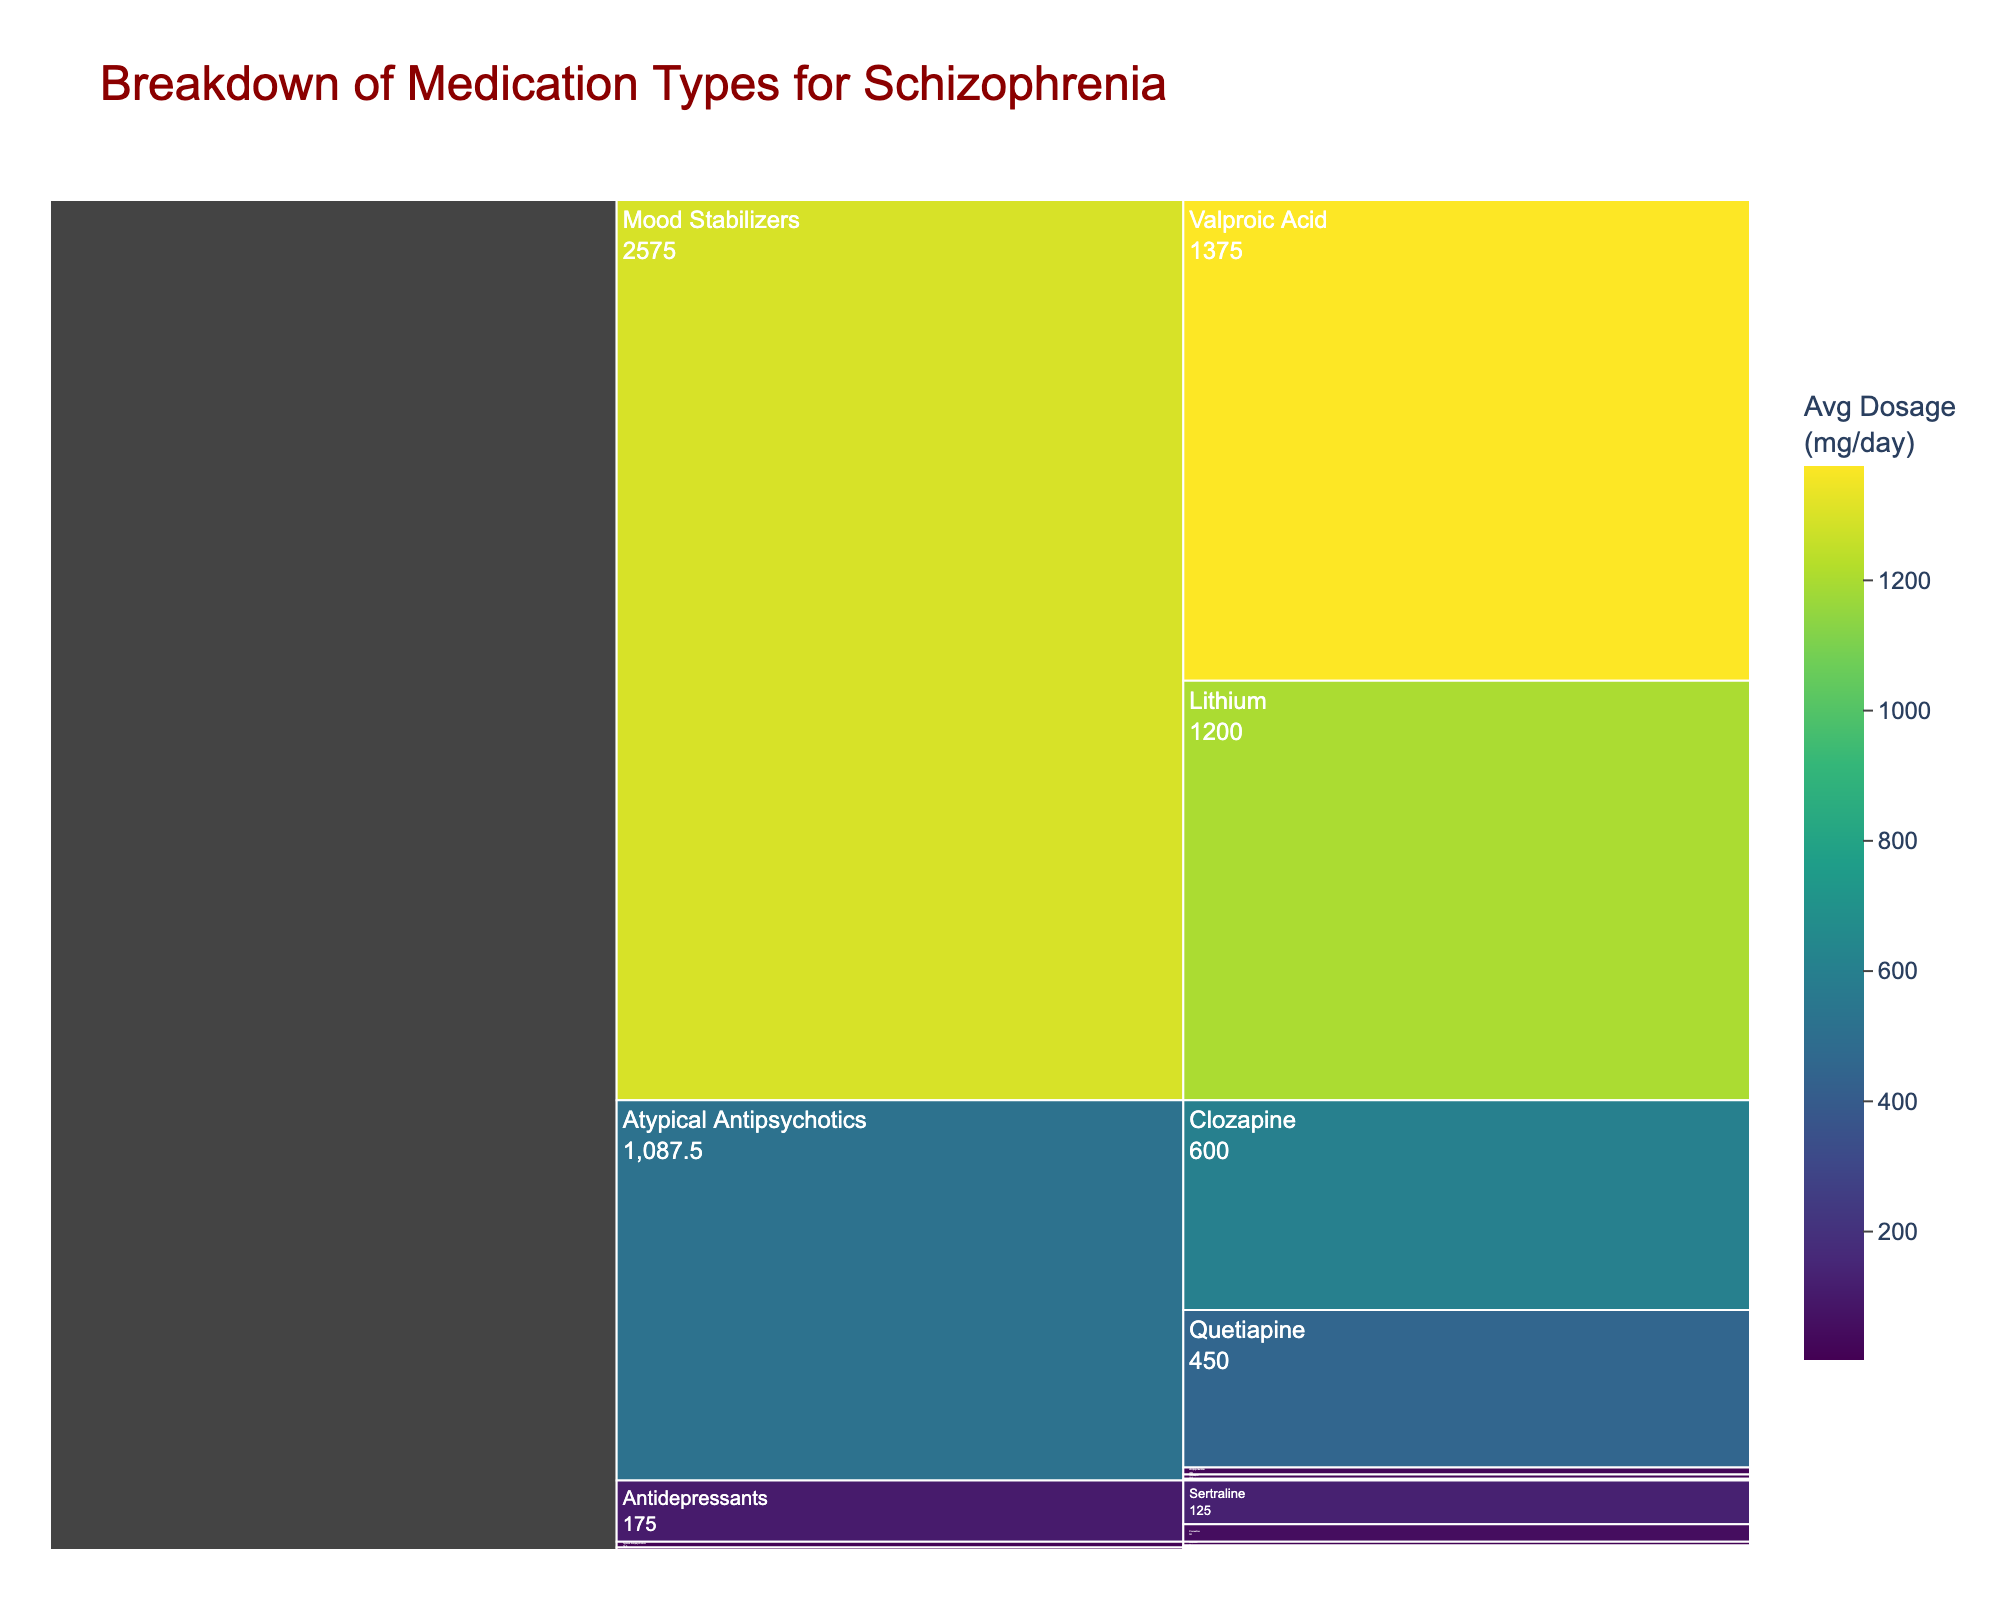How many chemical classes of medications are displayed in the chart? The chart shows different chemical classes under which medications are grouped. By counting the distinct categories on the top level of the icicle chart, we find the number of classes.
Answer: 4 Which medication has the highest average dosage in the chart? To find the medication with the highest average dosage, look for the segment with the highest numeric value in mg/day. Clozapine at 600 mg/day is highest.
Answer: Clozapine What is the total average dosage for all Typical Antipsychotics? Locate all Typical Antipsychotics (Haloperidol and Fluphenazine), then sum up their average dosages: (11 + 5.5) = 16.5 mg/day.
Answer: 16.5 mg/day Which chemical class has the most medications listed? Count the number of medications under each chemical class. Atypical Antipsychotics have the most medications listed.
Answer: Atypical Antipsychotics If you were to categorize the medications with an average dosage of over 500 mg/day, which ones would qualify? Identify the segments with dosages over 500 mg/day by their values in the visual. Both Quetiapine and Clozapine have average dosages over 500 mg/day.
Answer: Quetiapine, Clozapine Which Atypical Antipsychotic has the lowest average dosage? Among the Atypical Antipsychotics (Risperidone, Olanzapine, Quetiapine, Aripiprazole, Clozapine), find the one with the lowest average dosage value. Risperidone has the lowest at 5 mg/day.
Answer: Risperidone How are the colors related to the average dosage in the chart? The chart uses a continuous color scale (Viridis) to represent average dosages. Darker colors typically represent lower dosages, and brighter colors represent higher dosages.
Answer: Dark to bright Do Mood Stabilizers or Antidepressants have higher average dosages, overall? Calculate the average dosage for each category. Mood Stabilizers: (1200 + 1375)/2 = 1287.5 mg/day, Antidepressants: (125 + 50)/2 = 87.5 mg/day. Compare the sums, Mood Stabilizers are higher.
Answer: Mood Stabilizers Which medication has an average dosage of exactly 1 mg/day? By checking each segment's average dosage label, Lorazepam has an average dosage that matches exactly 1 mg/day.
Answer: Lorazepam 